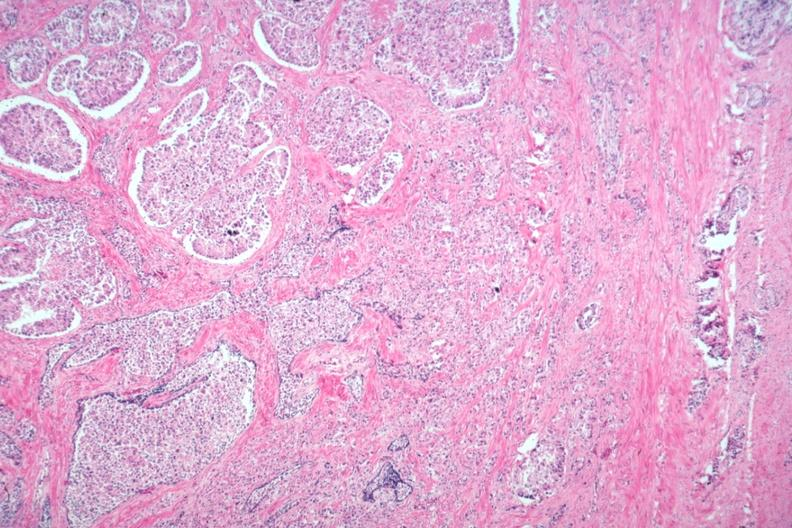does this image show typical lesion?
Answer the question using a single word or phrase. Yes 